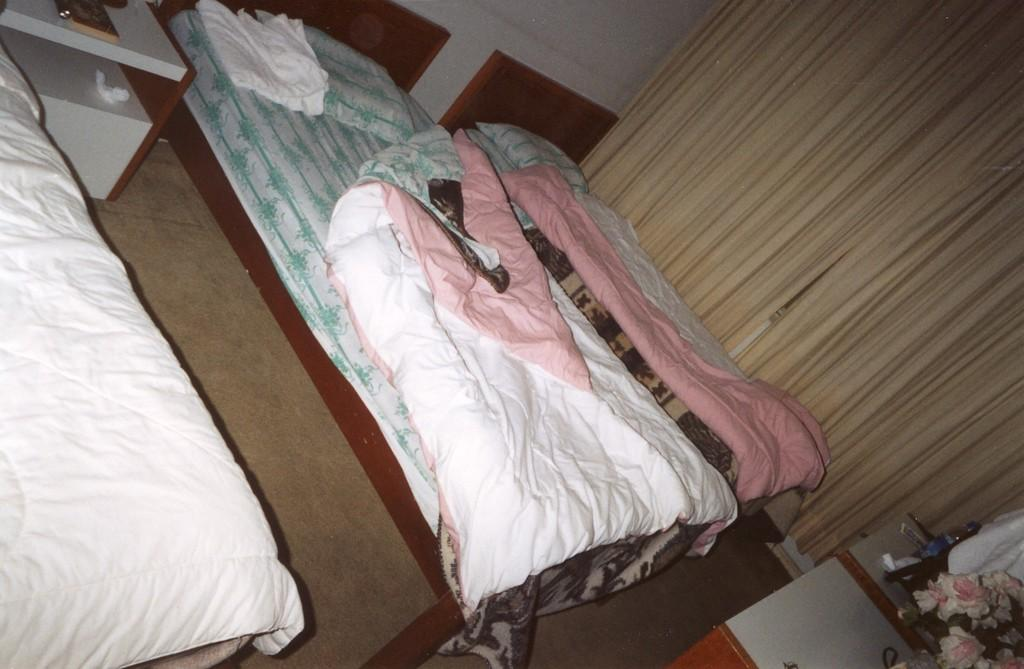What type of furniture can be seen in the image? There are beds and wooden tables in the image. What type of window treatment is present in the image? There are curtains in the image. What type of decorative element is present in the image? There are flowers in the image. What type of business is being conducted in the image? There is no indication of a business being conducted in the image. What type of voyage is depicted in the image? There is no voyage depicted in the image. 